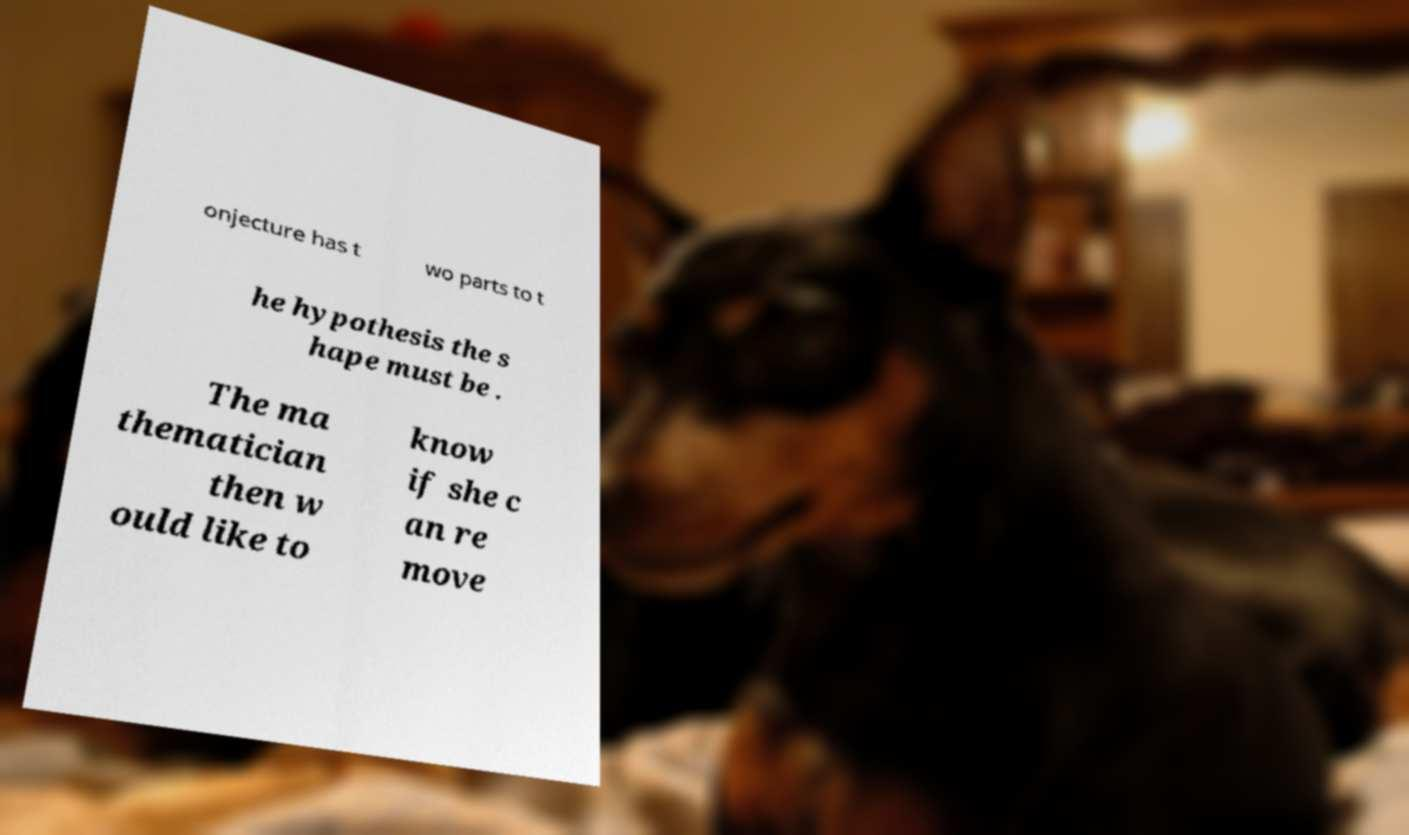For documentation purposes, I need the text within this image transcribed. Could you provide that? onjecture has t wo parts to t he hypothesis the s hape must be . The ma thematician then w ould like to know if she c an re move 